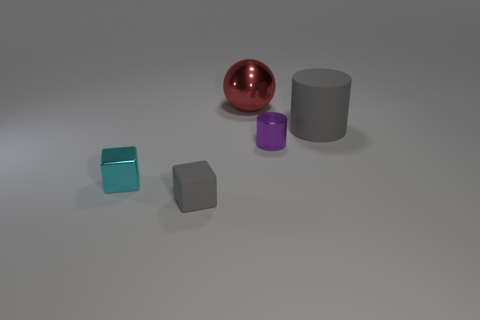There is a gray thing that is on the right side of the tiny gray matte cube; is it the same shape as the tiny thing right of the tiny gray thing? Yes, the object to the right of the small gray matte cube is a cylinder, which has the same shape as the smaller purple cylinder situated to the right of it. Both objects share the cylindrical shape with flat circular top and bottom surfaces and a curved side. 